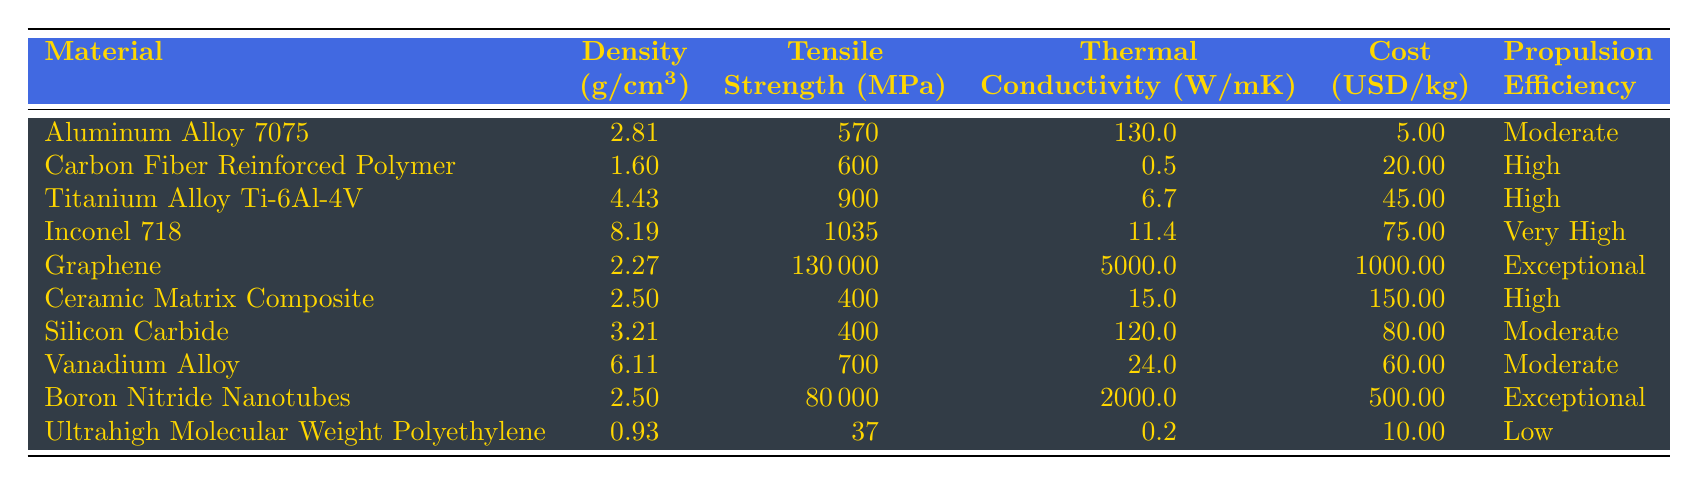What is the propulsion efficiency of Graphene? From the table, we can directly locate the row for Graphene, which states that its propulsion efficiency is "Exceptional."
Answer: Exceptional Which material has the highest tensile strength? Looking through the tensile strength values in the table, Graphene has a tensile strength of 130,000 MPa, which is higher than all the other materials listed.
Answer: Graphene What is the cost per kilogram of Inconel 718? The table provides the value directly next to Inconel 718, which is listed as $75.00 per kg.
Answer: 75.00 Are there any materials with low propulsion efficiency? Checking the propulsion efficiency column, we see that Ultrahigh Molecular Weight Polyethylene is listed with low propulsion efficiency. This indicates there is at least one material with low efficiency.
Answer: Yes Which material has the lowest density? By examining the density values, Ultrahigh Molecular Weight Polyethylene has the lowest density at 0.93 g/cm³, making it the lightest material on the list.
Answer: Ultrahigh Molecular Weight Polyethylene How much more expensive is Graphene than Aluminum Alloy 7075? Graphene costs $1000.00 per kg, while Aluminum Alloy 7075 costs $5.00 per kg. Calculating the difference gives us $1000.00 - $5.00 = $995.00.
Answer: 995.00 What is the average tensile strength of materials with high propulsion efficiency? The materials with high propulsion efficiency are CFRP, Titanium Alloy Ti-6Al-4V, Inconel 718, and Ceramic Matrix Composite. Their tensile strengths are 600, 900, 1035, and 400 MPa respectively. Summing them gives: 600 + 900 + 1035 + 400 = 2935 MPa. There are 4 materials, so the average is 2935 / 4 = 733.75 MPa.
Answer: 733.75 Which material with high propulsion efficiency has the lowest cost? The high propulsion efficiency materials are CFRP, Titanium Alloy Ti-6Al-4V, Inconel 718, and Ceramic Matrix Composite. Their costs are $20.00, $45.00, $75.00, and $150.00, respectively. Comparing these, CFRP has the lowest cost at $20.00 per kg.
Answer: CFRP Is the tensile strength of Silicon Carbide equal to that of Ceramic Matrix Composite? The table shows that Silicon Carbide has a tensile strength of 400 MPa and Ceramic Matrix Composite also has a tensile strength of 400 MPa. Therefore, they are equal.
Answer: Yes Which material has the highest thermal conductivity? From the table, Graphene has the highest thermal conductivity listed at 5000 W/mK, which is significantly higher than all the other materials.
Answer: Graphene How many materials listed have very high or exceptional propulsion efficiency? The materials with very high efficiency are Inconel 718 and the exceptional ones are Graphene and Boron Nitride Nanotubes. Thus, combining the two gives us a total of 3 materials.
Answer: 3 